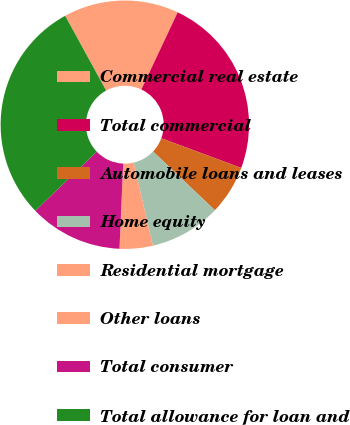Convert chart. <chart><loc_0><loc_0><loc_500><loc_500><pie_chart><fcel>Commercial real estate<fcel>Total commercial<fcel>Automobile loans and leases<fcel>Home equity<fcel>Residential mortgage<fcel>Other loans<fcel>Total consumer<fcel>Total allowance for loan and<nl><fcel>14.97%<fcel>23.66%<fcel>6.43%<fcel>9.28%<fcel>3.58%<fcel>0.73%<fcel>12.13%<fcel>29.21%<nl></chart> 